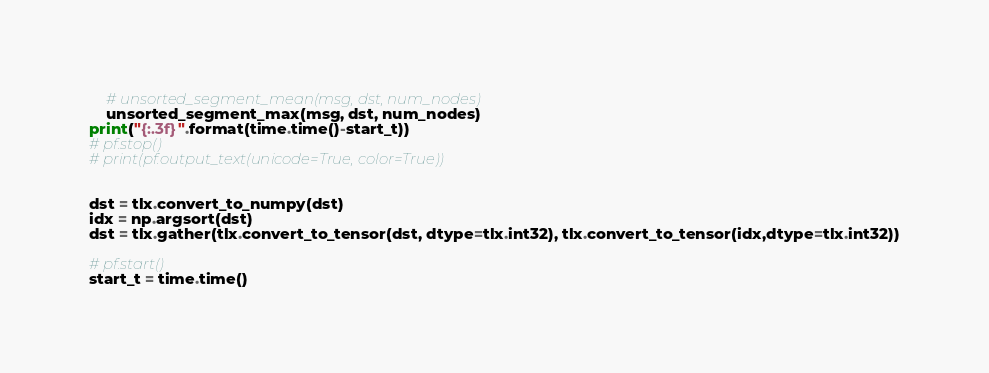Convert code to text. <code><loc_0><loc_0><loc_500><loc_500><_Python_>    # unsorted_segment_mean(msg, dst, num_nodes)
    unsorted_segment_max(msg, dst, num_nodes)
print("{:.3f}".format(time.time()-start_t))
# pf.stop()
# print(pf.output_text(unicode=True, color=True))


dst = tlx.convert_to_numpy(dst)
idx = np.argsort(dst)
dst = tlx.gather(tlx.convert_to_tensor(dst, dtype=tlx.int32), tlx.convert_to_tensor(idx,dtype=tlx.int32))

# pf.start()
start_t = time.time()</code> 